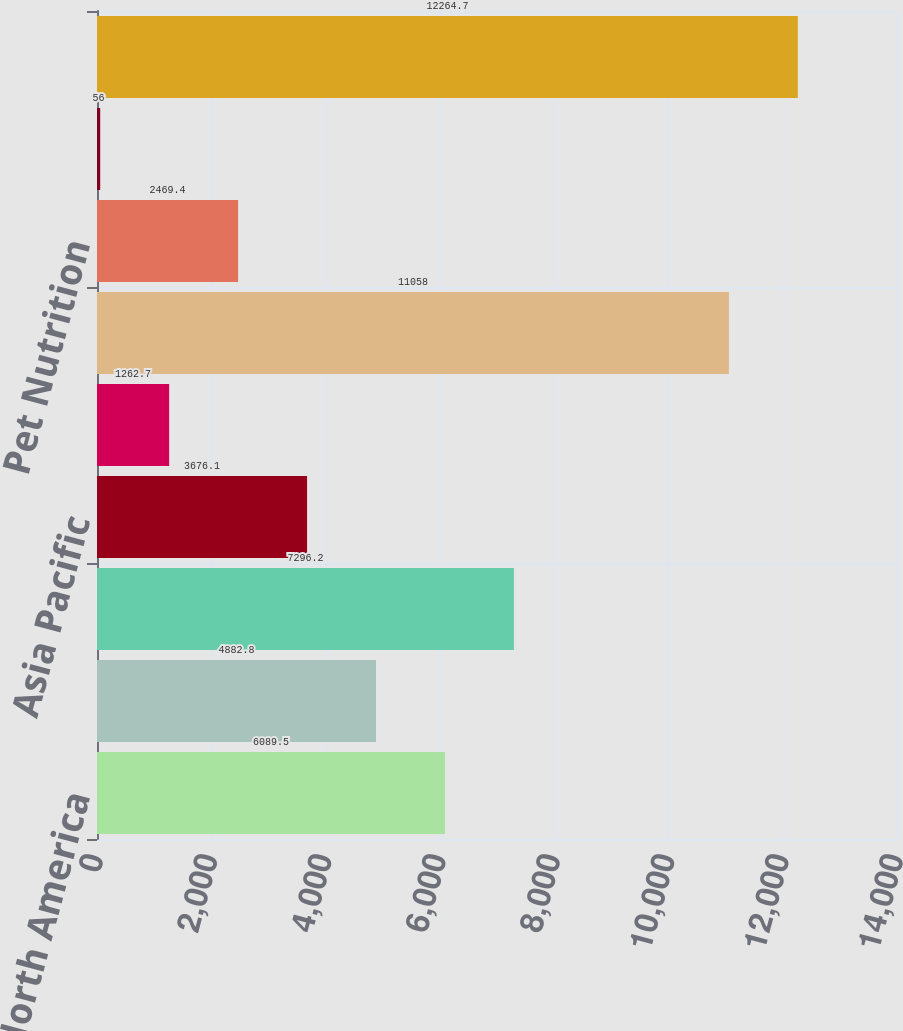Convert chart. <chart><loc_0><loc_0><loc_500><loc_500><bar_chart><fcel>North America<fcel>Latin America<fcel>Europe<fcel>Asia Pacific<fcel>Africa/Eurasia<fcel>Total Oral Personal and Home<fcel>Pet Nutrition<fcel>Corporate (1)<fcel>Total Identifiable assets (2)<nl><fcel>6089.5<fcel>4882.8<fcel>7296.2<fcel>3676.1<fcel>1262.7<fcel>11058<fcel>2469.4<fcel>56<fcel>12264.7<nl></chart> 